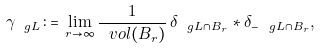Convert formula to latex. <formula><loc_0><loc_0><loc_500><loc_500>\gamma _ { \ g L } \, \colon = \, \lim _ { r \to \infty } \frac { 1 } { \ v o l ( B _ { r } ) } \, \delta _ { \ g L \cap B _ { r } } * \delta _ { - \ g L \cap B _ { r } } ,</formula> 